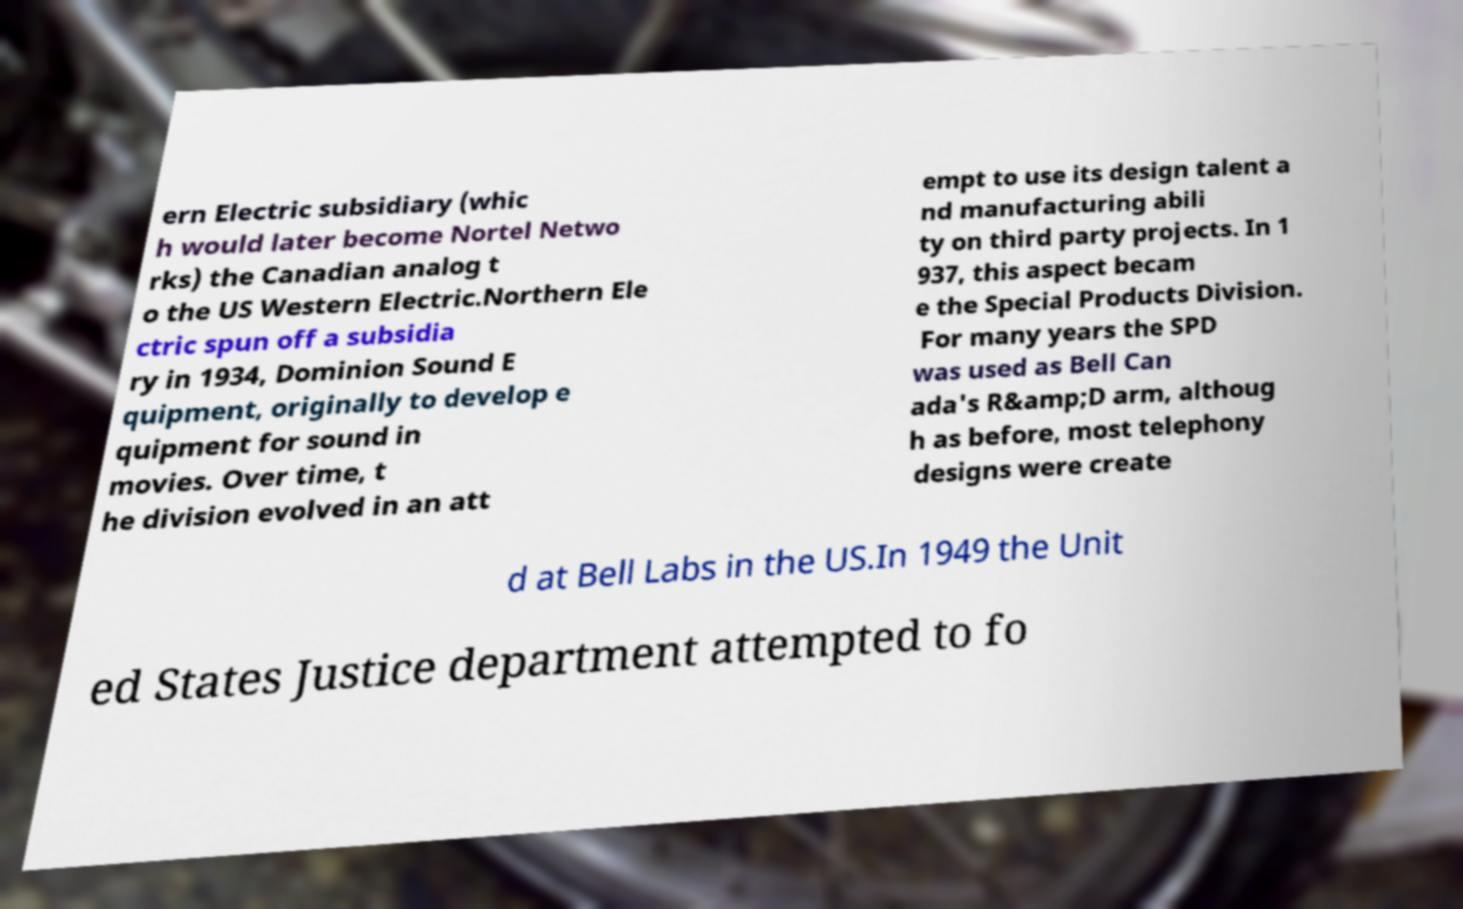What messages or text are displayed in this image? I need them in a readable, typed format. ern Electric subsidiary (whic h would later become Nortel Netwo rks) the Canadian analog t o the US Western Electric.Northern Ele ctric spun off a subsidia ry in 1934, Dominion Sound E quipment, originally to develop e quipment for sound in movies. Over time, t he division evolved in an att empt to use its design talent a nd manufacturing abili ty on third party projects. In 1 937, this aspect becam e the Special Products Division. For many years the SPD was used as Bell Can ada's R&amp;D arm, althoug h as before, most telephony designs were create d at Bell Labs in the US.In 1949 the Unit ed States Justice department attempted to fo 